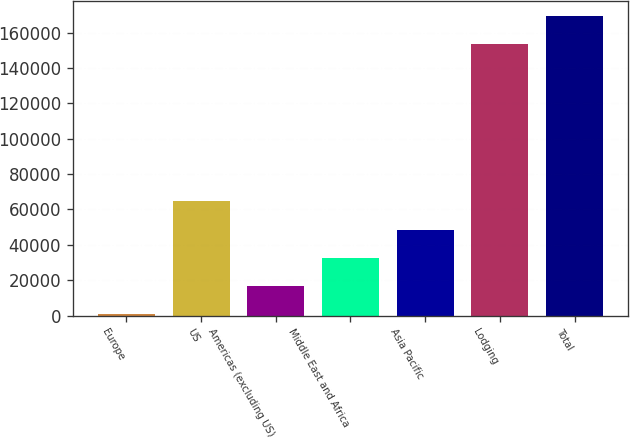<chart> <loc_0><loc_0><loc_500><loc_500><bar_chart><fcel>Europe<fcel>US<fcel>Americas (excluding US)<fcel>Middle East and Africa<fcel>Asia Pacific<fcel>Lodging<fcel>Total<nl><fcel>705<fcel>64594.2<fcel>16677.3<fcel>32649.6<fcel>48621.9<fcel>153634<fcel>169606<nl></chart> 